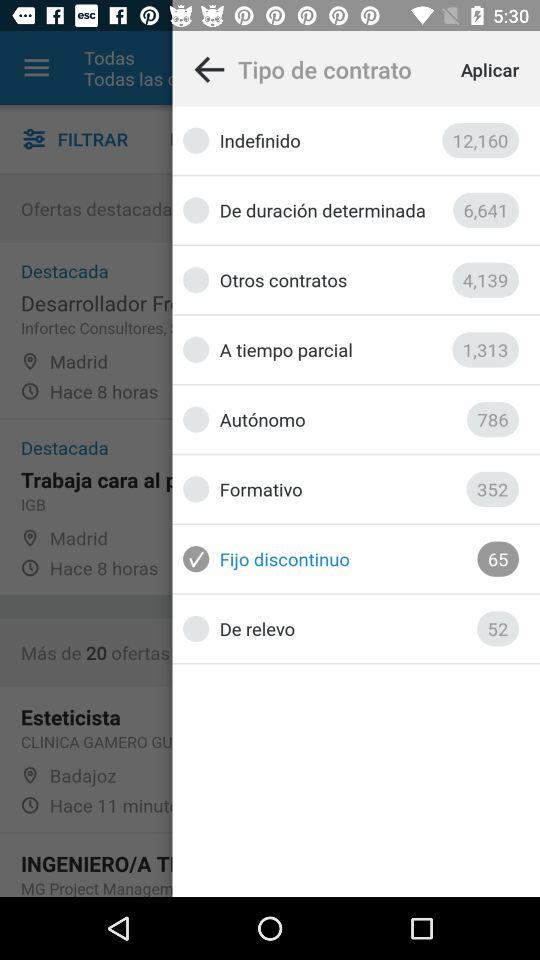How many more offers are there for indefinido than for de duración determinada?
Answer the question using a single word or phrase. 5519 